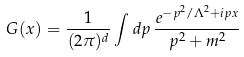<formula> <loc_0><loc_0><loc_500><loc_500>G ( x ) = \frac { 1 } { ( 2 \pi ) ^ { d } } \int d p \, \frac { e ^ { - p ^ { 2 } / \Lambda ^ { 2 } + i p x } } { p ^ { 2 } + m ^ { 2 } }</formula> 